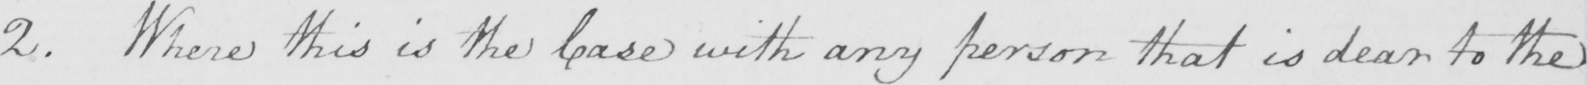Please transcribe the handwritten text in this image. 2 . Where this is the Case with any person that is dear to the 